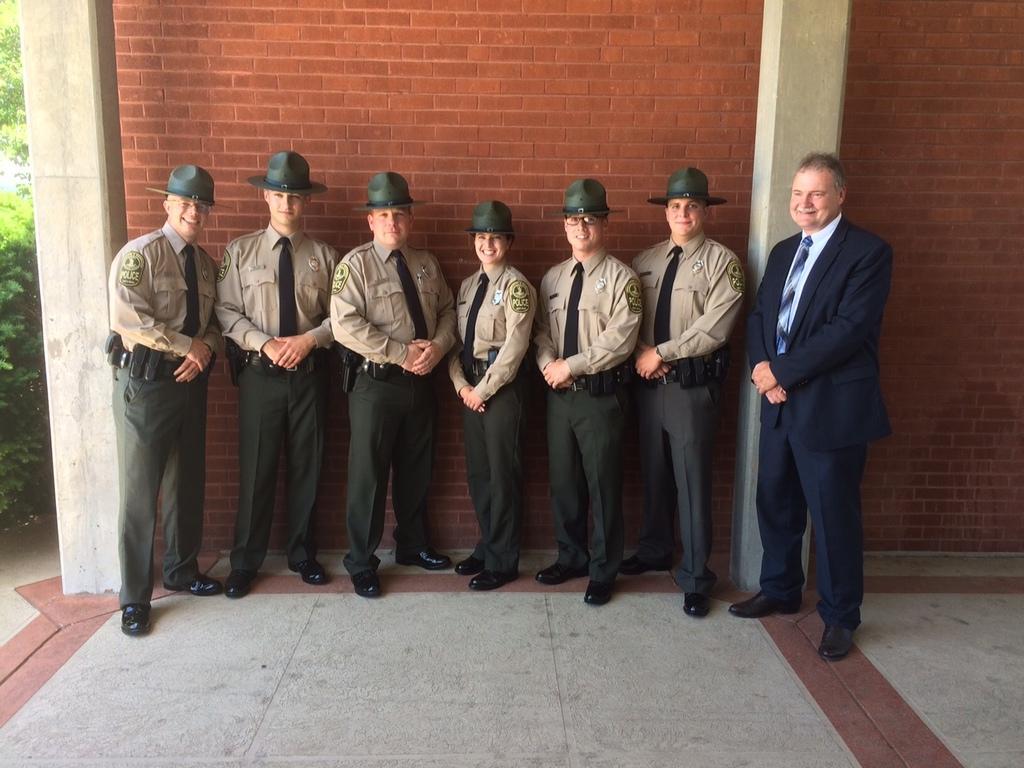Can you describe this image briefly? In this picture I can observe group of people. Most of them are wearing hats on their heads. In the background I can observe wall. 